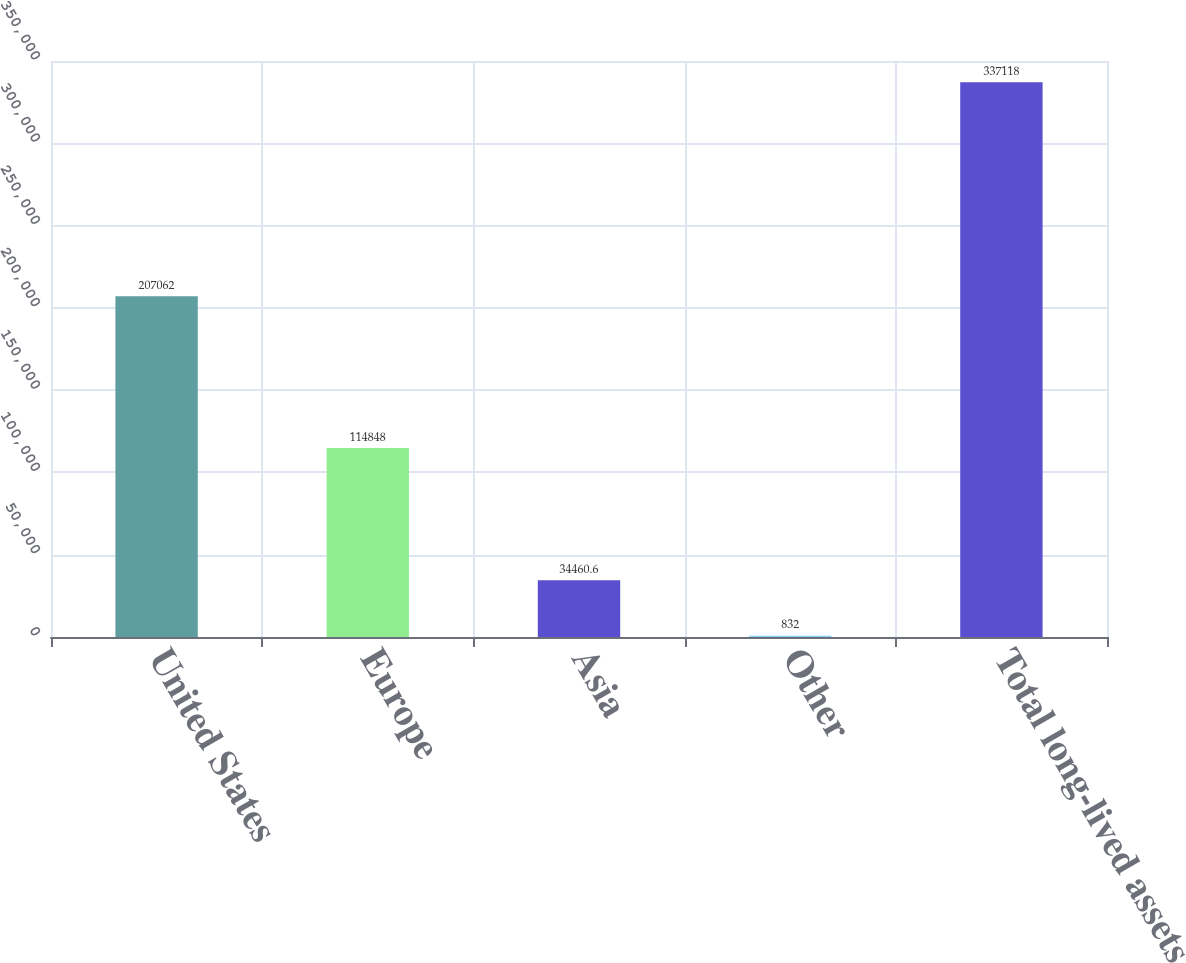Convert chart. <chart><loc_0><loc_0><loc_500><loc_500><bar_chart><fcel>United States<fcel>Europe<fcel>Asia<fcel>Other<fcel>Total long-lived assets<nl><fcel>207062<fcel>114848<fcel>34460.6<fcel>832<fcel>337118<nl></chart> 